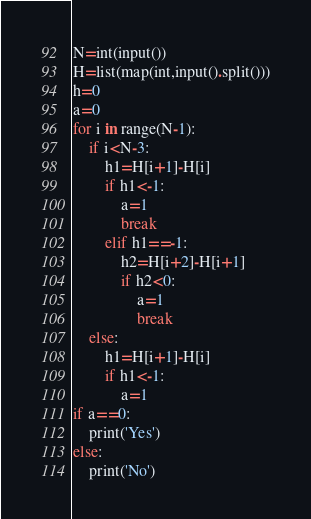<code> <loc_0><loc_0><loc_500><loc_500><_Python_>N=int(input())
H=list(map(int,input().split()))
h=0
a=0
for i in range(N-1):
    if i<N-3:
        h1=H[i+1]-H[i]
        if h1<-1:
            a=1
            break
        elif h1==-1:
            h2=H[i+2]-H[i+1]
            if h2<0:
                a=1
                break
    else:
        h1=H[i+1]-H[i]
        if h1<-1:
            a=1
if a==0:
    print('Yes')
else:
    print('No')</code> 